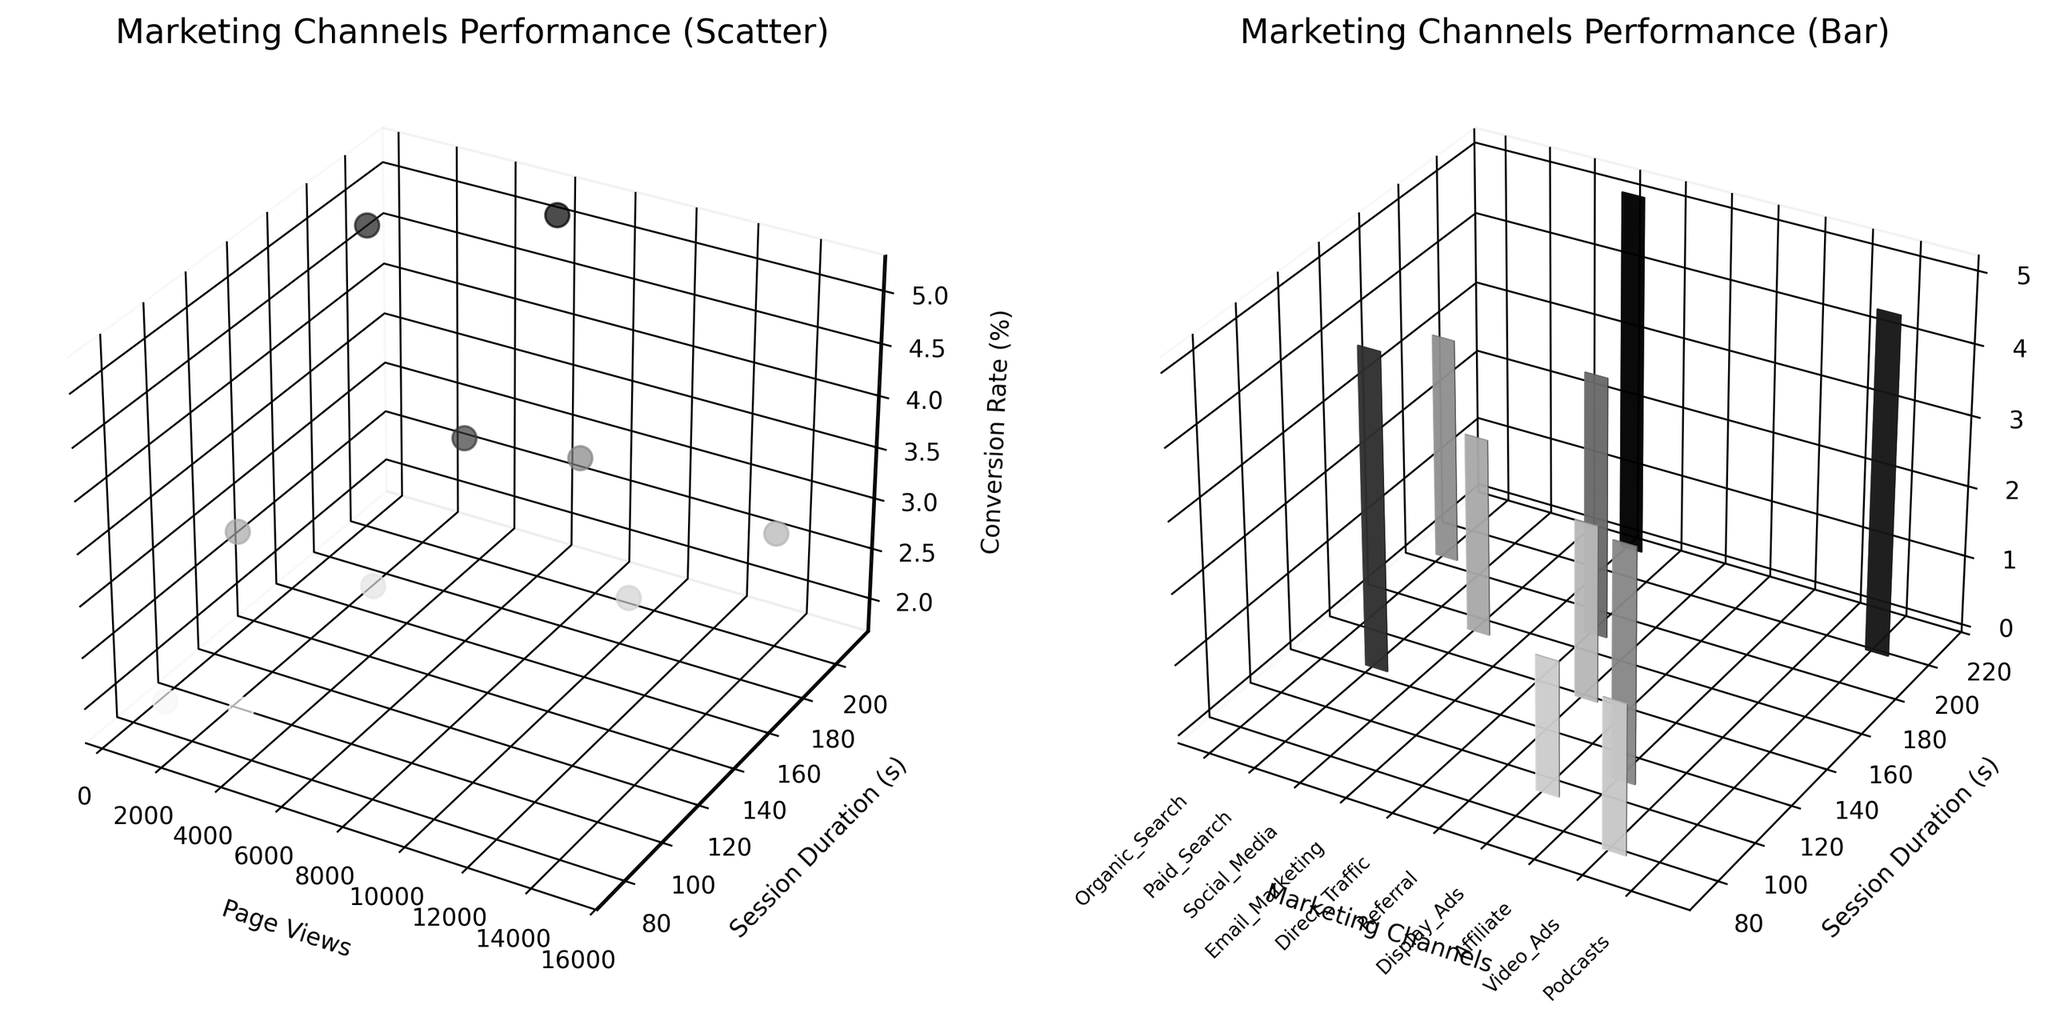How many marketing channels are presented in the figures? There are different colors and labels for each data point/bar in the figures. By counting the unique colors or labels, we see there are 10 marketing channels.
Answer: 10 Which marketing channel has the highest conversion rate? By observing the z-axis values in both plots, it's clear that Email Marketing has the highest conversion rate at 5.1%.
Answer: Email Marketing Which marketing channels have session durations greater than 180 seconds? Consulting the y-axis values, Organic Search (180s) and Email Marketing (210s) fall into or above the threshold.
Answer: Organic Search, Email Marketing Which marketing channel has the lowest page views? By observing the x-axis in both charts, Podcasts has the fewest page views.
Answer: Podcasts Which marketing channel has a higher conversion rate, Paid Search or Direct Traffic? By comparing the z-axis values, Direct Traffic has a conversion rate of 3.7% while Paid Search has 4.5%.
Answer: Paid Search What is the combined session duration for Social Media and Referral? Adding the session durations from the y-axis values, Social Media (150s) and Referral (135s), the total is 150 + 135 = 285 seconds.
Answer: 285 seconds How do Organic Search and Social Media compare in terms of page views and conversion rates? Organic Search has more page views (15000) compared to Social Media (12000), and a higher conversion rate (3.2% vs 2.8%).
Answer: Organic Search has more page views and a higher conversion rate Based on the scatter plot, which marketing channel has relatively low page views but a high conversion rate? From the scatter plot, Email Marketing has moderate page views (6000) but the highest conversion rate (5.1%).
Answer: Email Marketing Is there any marketing channel with both below-average page views and above-average session duration? The average page views can be estimated around the central cluster (~7000-8500). Email Marketing has 6000 page views (below-average) and 210s session duration (above-average).
Answer: Email Marketing 